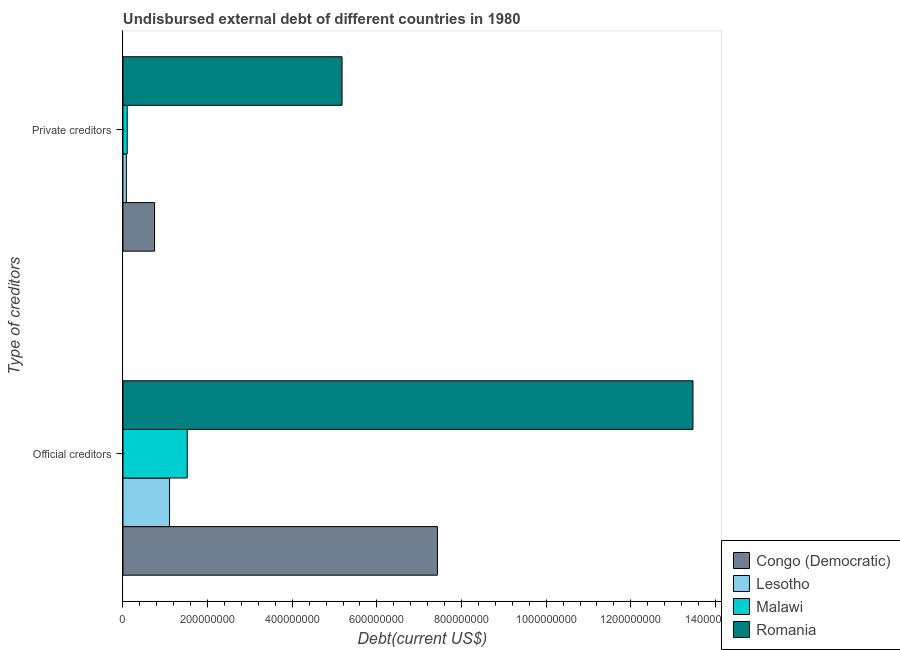How many groups of bars are there?
Give a very brief answer. 2. Are the number of bars on each tick of the Y-axis equal?
Keep it short and to the point. Yes. How many bars are there on the 2nd tick from the top?
Make the answer very short. 4. What is the label of the 2nd group of bars from the top?
Keep it short and to the point. Official creditors. What is the undisbursed external debt of official creditors in Romania?
Keep it short and to the point. 1.35e+09. Across all countries, what is the maximum undisbursed external debt of official creditors?
Give a very brief answer. 1.35e+09. Across all countries, what is the minimum undisbursed external debt of official creditors?
Keep it short and to the point. 1.10e+08. In which country was the undisbursed external debt of official creditors maximum?
Keep it short and to the point. Romania. In which country was the undisbursed external debt of official creditors minimum?
Your answer should be very brief. Lesotho. What is the total undisbursed external debt of private creditors in the graph?
Offer a very short reply. 6.10e+08. What is the difference between the undisbursed external debt of official creditors in Malawi and that in Congo (Democratic)?
Make the answer very short. -5.91e+08. What is the difference between the undisbursed external debt of official creditors in Malawi and the undisbursed external debt of private creditors in Lesotho?
Offer a terse response. 1.44e+08. What is the average undisbursed external debt of private creditors per country?
Your response must be concise. 1.53e+08. What is the difference between the undisbursed external debt of private creditors and undisbursed external debt of official creditors in Malawi?
Keep it short and to the point. -1.42e+08. In how many countries, is the undisbursed external debt of official creditors greater than 960000000 US$?
Make the answer very short. 1. What is the ratio of the undisbursed external debt of official creditors in Congo (Democratic) to that in Lesotho?
Your answer should be very brief. 6.75. What does the 2nd bar from the top in Private creditors represents?
Ensure brevity in your answer.  Malawi. What does the 2nd bar from the bottom in Private creditors represents?
Make the answer very short. Lesotho. How many countries are there in the graph?
Your response must be concise. 4. Does the graph contain any zero values?
Your answer should be very brief. No. What is the title of the graph?
Offer a very short reply. Undisbursed external debt of different countries in 1980. What is the label or title of the X-axis?
Offer a terse response. Debt(current US$). What is the label or title of the Y-axis?
Ensure brevity in your answer.  Type of creditors. What is the Debt(current US$) of Congo (Democratic) in Official creditors?
Offer a terse response. 7.43e+08. What is the Debt(current US$) in Lesotho in Official creditors?
Make the answer very short. 1.10e+08. What is the Debt(current US$) of Malawi in Official creditors?
Your answer should be very brief. 1.52e+08. What is the Debt(current US$) of Romania in Official creditors?
Provide a succinct answer. 1.35e+09. What is the Debt(current US$) of Congo (Democratic) in Private creditors?
Provide a succinct answer. 7.47e+07. What is the Debt(current US$) in Lesotho in Private creditors?
Make the answer very short. 8.00e+06. What is the Debt(current US$) of Malawi in Private creditors?
Your answer should be very brief. 1.00e+07. What is the Debt(current US$) of Romania in Private creditors?
Your response must be concise. 5.18e+08. Across all Type of creditors, what is the maximum Debt(current US$) of Congo (Democratic)?
Your answer should be very brief. 7.43e+08. Across all Type of creditors, what is the maximum Debt(current US$) in Lesotho?
Ensure brevity in your answer.  1.10e+08. Across all Type of creditors, what is the maximum Debt(current US$) in Malawi?
Offer a very short reply. 1.52e+08. Across all Type of creditors, what is the maximum Debt(current US$) of Romania?
Your answer should be very brief. 1.35e+09. Across all Type of creditors, what is the minimum Debt(current US$) of Congo (Democratic)?
Offer a terse response. 7.47e+07. Across all Type of creditors, what is the minimum Debt(current US$) of Lesotho?
Provide a succinct answer. 8.00e+06. Across all Type of creditors, what is the minimum Debt(current US$) of Malawi?
Your answer should be compact. 1.00e+07. Across all Type of creditors, what is the minimum Debt(current US$) of Romania?
Your answer should be compact. 5.18e+08. What is the total Debt(current US$) in Congo (Democratic) in the graph?
Provide a short and direct response. 8.18e+08. What is the total Debt(current US$) in Lesotho in the graph?
Your answer should be very brief. 1.18e+08. What is the total Debt(current US$) in Malawi in the graph?
Ensure brevity in your answer.  1.62e+08. What is the total Debt(current US$) in Romania in the graph?
Your answer should be compact. 1.86e+09. What is the difference between the Debt(current US$) of Congo (Democratic) in Official creditors and that in Private creditors?
Your answer should be very brief. 6.68e+08. What is the difference between the Debt(current US$) of Lesotho in Official creditors and that in Private creditors?
Your response must be concise. 1.02e+08. What is the difference between the Debt(current US$) of Malawi in Official creditors and that in Private creditors?
Your answer should be very brief. 1.42e+08. What is the difference between the Debt(current US$) of Romania in Official creditors and that in Private creditors?
Provide a short and direct response. 8.29e+08. What is the difference between the Debt(current US$) in Congo (Democratic) in Official creditors and the Debt(current US$) in Lesotho in Private creditors?
Your answer should be compact. 7.35e+08. What is the difference between the Debt(current US$) of Congo (Democratic) in Official creditors and the Debt(current US$) of Malawi in Private creditors?
Offer a very short reply. 7.33e+08. What is the difference between the Debt(current US$) of Congo (Democratic) in Official creditors and the Debt(current US$) of Romania in Private creditors?
Your response must be concise. 2.25e+08. What is the difference between the Debt(current US$) of Lesotho in Official creditors and the Debt(current US$) of Malawi in Private creditors?
Offer a very short reply. 1.00e+08. What is the difference between the Debt(current US$) of Lesotho in Official creditors and the Debt(current US$) of Romania in Private creditors?
Give a very brief answer. -4.08e+08. What is the difference between the Debt(current US$) of Malawi in Official creditors and the Debt(current US$) of Romania in Private creditors?
Provide a succinct answer. -3.66e+08. What is the average Debt(current US$) of Congo (Democratic) per Type of creditors?
Make the answer very short. 4.09e+08. What is the average Debt(current US$) in Lesotho per Type of creditors?
Make the answer very short. 5.90e+07. What is the average Debt(current US$) of Malawi per Type of creditors?
Your response must be concise. 8.10e+07. What is the average Debt(current US$) of Romania per Type of creditors?
Provide a succinct answer. 9.32e+08. What is the difference between the Debt(current US$) in Congo (Democratic) and Debt(current US$) in Lesotho in Official creditors?
Offer a terse response. 6.33e+08. What is the difference between the Debt(current US$) of Congo (Democratic) and Debt(current US$) of Malawi in Official creditors?
Your answer should be very brief. 5.91e+08. What is the difference between the Debt(current US$) in Congo (Democratic) and Debt(current US$) in Romania in Official creditors?
Keep it short and to the point. -6.04e+08. What is the difference between the Debt(current US$) of Lesotho and Debt(current US$) of Malawi in Official creditors?
Make the answer very short. -4.19e+07. What is the difference between the Debt(current US$) in Lesotho and Debt(current US$) in Romania in Official creditors?
Keep it short and to the point. -1.24e+09. What is the difference between the Debt(current US$) of Malawi and Debt(current US$) of Romania in Official creditors?
Ensure brevity in your answer.  -1.20e+09. What is the difference between the Debt(current US$) of Congo (Democratic) and Debt(current US$) of Lesotho in Private creditors?
Offer a very short reply. 6.67e+07. What is the difference between the Debt(current US$) in Congo (Democratic) and Debt(current US$) in Malawi in Private creditors?
Ensure brevity in your answer.  6.47e+07. What is the difference between the Debt(current US$) in Congo (Democratic) and Debt(current US$) in Romania in Private creditors?
Provide a short and direct response. -4.43e+08. What is the difference between the Debt(current US$) in Lesotho and Debt(current US$) in Malawi in Private creditors?
Your response must be concise. -2.01e+06. What is the difference between the Debt(current US$) in Lesotho and Debt(current US$) in Romania in Private creditors?
Offer a terse response. -5.10e+08. What is the difference between the Debt(current US$) in Malawi and Debt(current US$) in Romania in Private creditors?
Provide a succinct answer. -5.08e+08. What is the ratio of the Debt(current US$) in Congo (Democratic) in Official creditors to that in Private creditors?
Provide a succinct answer. 9.95. What is the ratio of the Debt(current US$) of Lesotho in Official creditors to that in Private creditors?
Provide a short and direct response. 13.75. What is the ratio of the Debt(current US$) in Malawi in Official creditors to that in Private creditors?
Your response must be concise. 15.18. What is the ratio of the Debt(current US$) in Romania in Official creditors to that in Private creditors?
Your answer should be compact. 2.6. What is the difference between the highest and the second highest Debt(current US$) in Congo (Democratic)?
Provide a short and direct response. 6.68e+08. What is the difference between the highest and the second highest Debt(current US$) in Lesotho?
Keep it short and to the point. 1.02e+08. What is the difference between the highest and the second highest Debt(current US$) of Malawi?
Your answer should be compact. 1.42e+08. What is the difference between the highest and the second highest Debt(current US$) of Romania?
Your response must be concise. 8.29e+08. What is the difference between the highest and the lowest Debt(current US$) of Congo (Democratic)?
Your answer should be very brief. 6.68e+08. What is the difference between the highest and the lowest Debt(current US$) in Lesotho?
Your answer should be compact. 1.02e+08. What is the difference between the highest and the lowest Debt(current US$) in Malawi?
Your answer should be very brief. 1.42e+08. What is the difference between the highest and the lowest Debt(current US$) of Romania?
Your answer should be compact. 8.29e+08. 